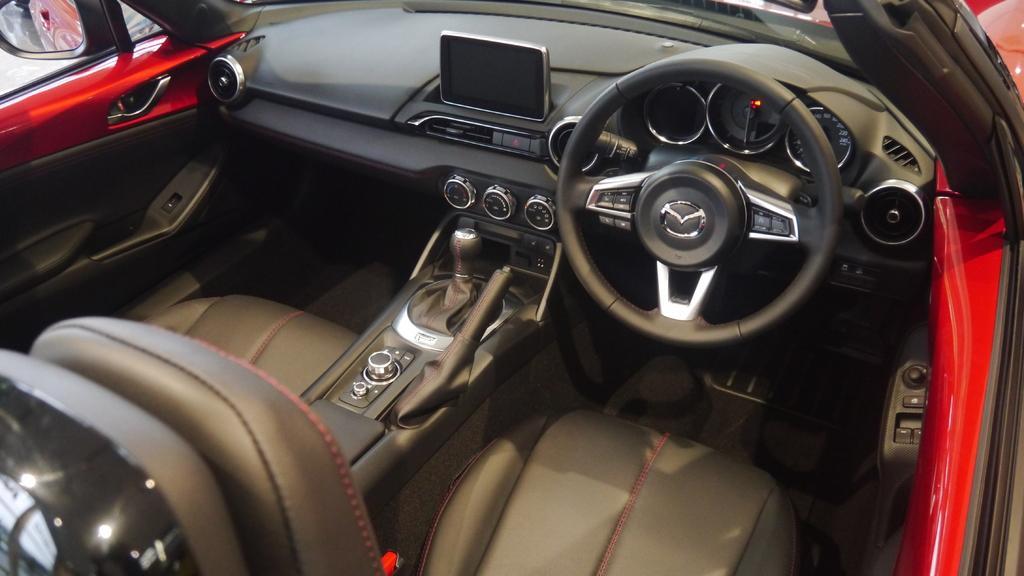Can you describe this image briefly? This picture is clicked inside the red color car. In the foreground we can see the seats, steering wheel and many other objects of the car. On the left corner we can see the door and a mirror. 